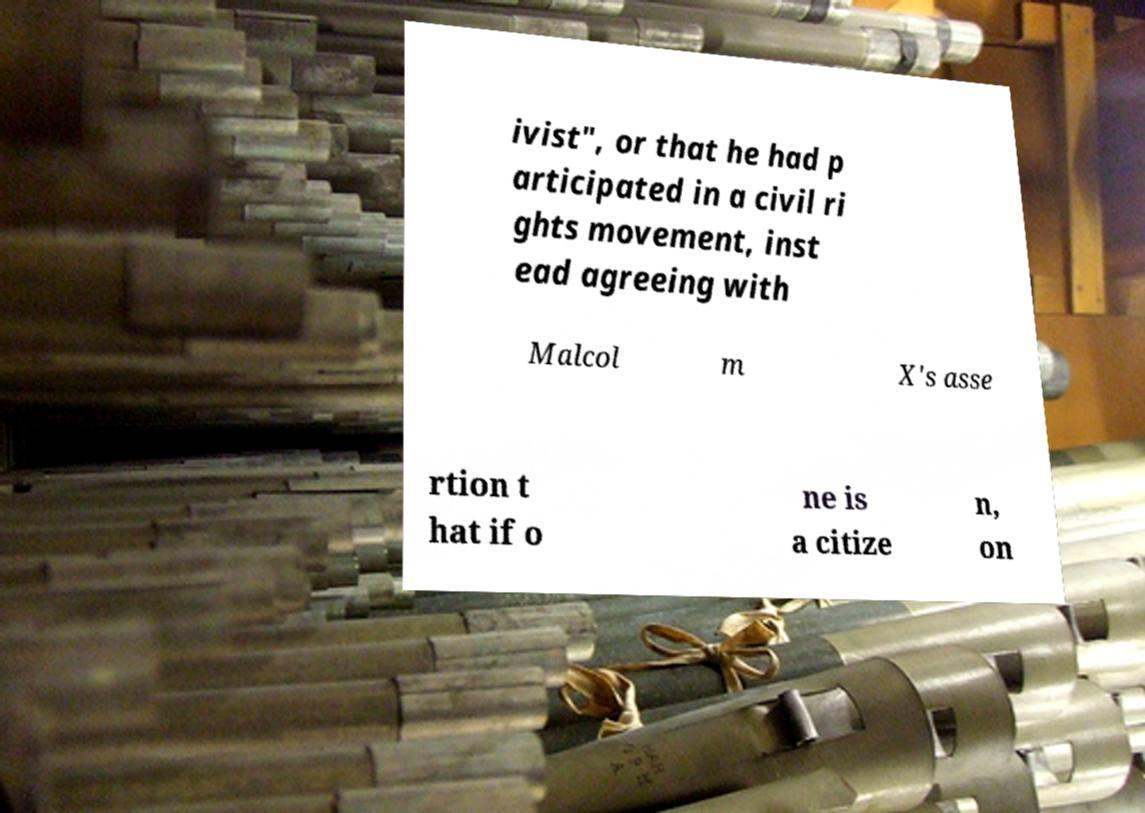For documentation purposes, I need the text within this image transcribed. Could you provide that? ivist", or that he had p articipated in a civil ri ghts movement, inst ead agreeing with Malcol m X's asse rtion t hat if o ne is a citize n, on 